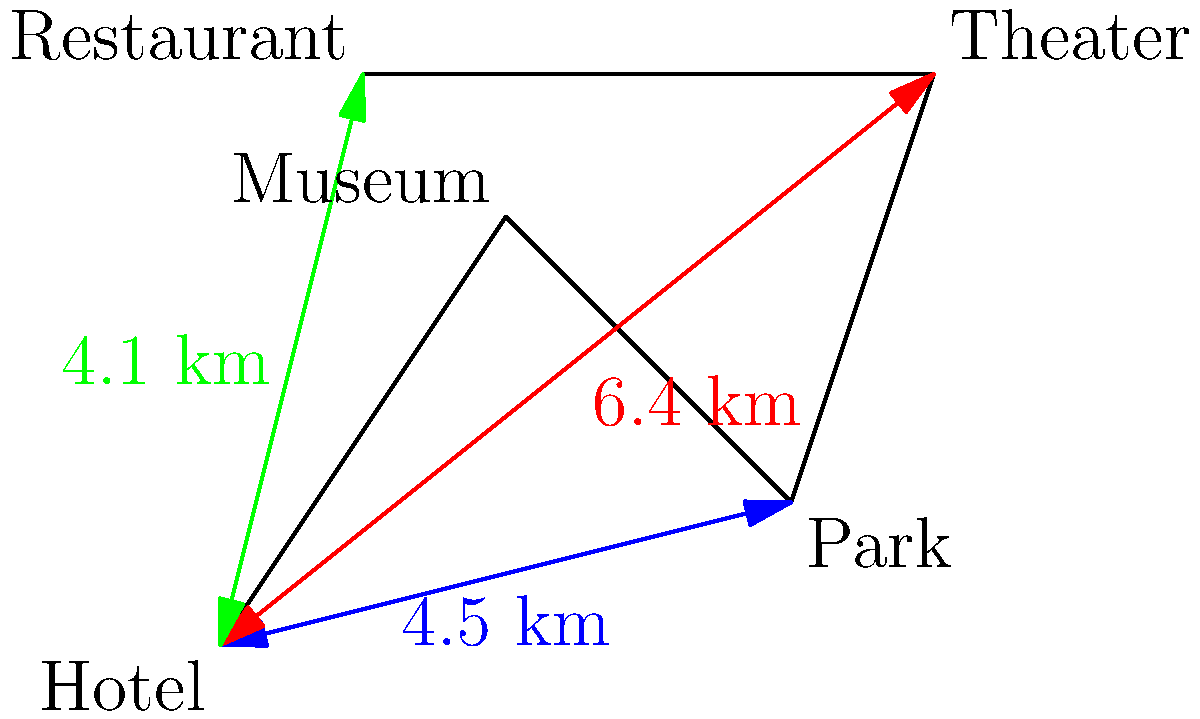Based on the city map provided, which attraction is the farthest from the hotel, and what is the optimal route to visit all attractions while minimizing travel distance? To answer this question, we need to analyze the distances and locations of each attraction relative to the hotel:

1. Calculate distances from the hotel to each attraction:
   - Hotel to Museum: Not given, but visually closer than others
   - Hotel to Park: 4.5 km
   - Hotel to Theater: 6.4 km
   - Hotel to Restaurant: 4.1 km

2. Identify the farthest attraction:
   The Theater is the farthest at 6.4 km from the hotel.

3. Determine the optimal route:
   a) Start at the Hotel
   b) Visit the Museum first (closest visually)
   c) Then go to the Restaurant (4.1 km from Hotel, but closer to Museum)
   d) Next, visit the Park (4.5 km from Hotel, but closer to Restaurant)
   e) Finally, end at the Theater (6.4 km from Hotel, but closest to Park)
   f) Return to Hotel

This route minimizes backtracking and ensures each attraction is visited while keeping the overall distance traveled to a minimum.
Answer: Theater (6.4 km); Hotel → Museum → Restaurant → Park → Theater → Hotel 